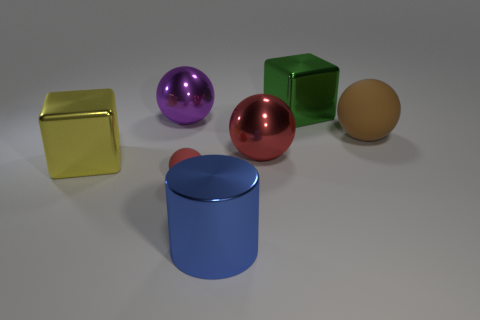How does the size of the egg-colored sphere compare to the other objects? The egg-colored sphere is considerably smaller than the majority of the other shapes. Compared to the cubes and the cylinder, it appears to be less than half their size in diameter, and it's almost the same size but slightly larger than the tiny purple ball. 